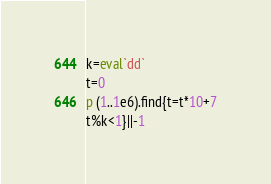<code> <loc_0><loc_0><loc_500><loc_500><_Ruby_>k=eval`dd`
t=0
p (1..1e6).find{t=t*10+7
t%k<1}||-1</code> 